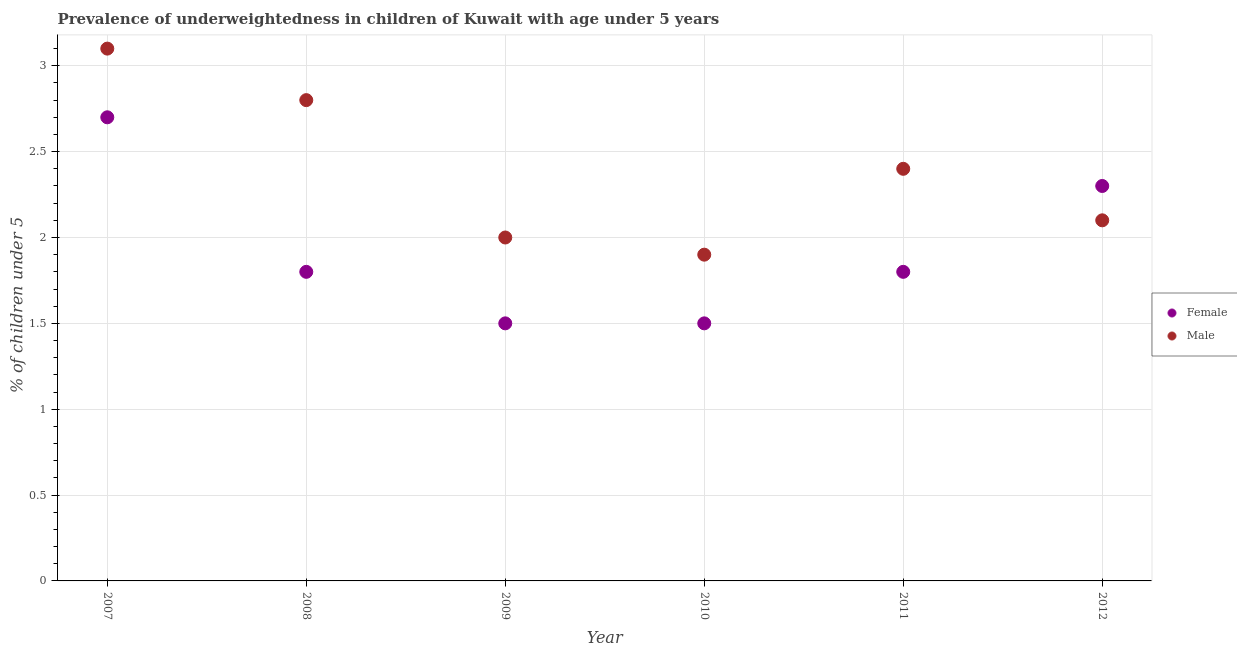How many different coloured dotlines are there?
Provide a short and direct response. 2. What is the percentage of underweighted female children in 2009?
Your answer should be very brief. 1.5. Across all years, what is the maximum percentage of underweighted male children?
Your answer should be compact. 3.1. Across all years, what is the minimum percentage of underweighted male children?
Your response must be concise. 1.9. In which year was the percentage of underweighted female children maximum?
Keep it short and to the point. 2007. In which year was the percentage of underweighted male children minimum?
Offer a terse response. 2010. What is the total percentage of underweighted male children in the graph?
Your response must be concise. 14.3. What is the difference between the percentage of underweighted female children in 2009 and that in 2011?
Provide a short and direct response. -0.3. What is the difference between the percentage of underweighted male children in 2010 and the percentage of underweighted female children in 2008?
Provide a succinct answer. 0.1. What is the average percentage of underweighted female children per year?
Make the answer very short. 1.93. In the year 2009, what is the difference between the percentage of underweighted male children and percentage of underweighted female children?
Ensure brevity in your answer.  0.5. What is the ratio of the percentage of underweighted female children in 2007 to that in 2011?
Give a very brief answer. 1.5. What is the difference between the highest and the second highest percentage of underweighted female children?
Offer a very short reply. 0.4. What is the difference between the highest and the lowest percentage of underweighted male children?
Your answer should be compact. 1.2. In how many years, is the percentage of underweighted female children greater than the average percentage of underweighted female children taken over all years?
Provide a short and direct response. 2. Does the percentage of underweighted female children monotonically increase over the years?
Provide a short and direct response. No. How many dotlines are there?
Offer a very short reply. 2. Are the values on the major ticks of Y-axis written in scientific E-notation?
Offer a very short reply. No. Does the graph contain any zero values?
Provide a succinct answer. No. Does the graph contain grids?
Offer a terse response. Yes. How are the legend labels stacked?
Provide a succinct answer. Vertical. What is the title of the graph?
Offer a very short reply. Prevalence of underweightedness in children of Kuwait with age under 5 years. Does "Nitrous oxide emissions" appear as one of the legend labels in the graph?
Offer a terse response. No. What is the label or title of the X-axis?
Keep it short and to the point. Year. What is the label or title of the Y-axis?
Ensure brevity in your answer.   % of children under 5. What is the  % of children under 5 in Female in 2007?
Provide a succinct answer. 2.7. What is the  % of children under 5 in Male in 2007?
Provide a succinct answer. 3.1. What is the  % of children under 5 in Female in 2008?
Offer a terse response. 1.8. What is the  % of children under 5 of Male in 2008?
Make the answer very short. 2.8. What is the  % of children under 5 of Female in 2009?
Offer a very short reply. 1.5. What is the  % of children under 5 in Male in 2010?
Keep it short and to the point. 1.9. What is the  % of children under 5 in Female in 2011?
Give a very brief answer. 1.8. What is the  % of children under 5 of Male in 2011?
Your answer should be compact. 2.4. What is the  % of children under 5 in Female in 2012?
Give a very brief answer. 2.3. What is the  % of children under 5 in Male in 2012?
Your answer should be very brief. 2.1. Across all years, what is the maximum  % of children under 5 of Female?
Your answer should be compact. 2.7. Across all years, what is the maximum  % of children under 5 of Male?
Your response must be concise. 3.1. Across all years, what is the minimum  % of children under 5 of Female?
Your answer should be compact. 1.5. Across all years, what is the minimum  % of children under 5 of Male?
Keep it short and to the point. 1.9. What is the total  % of children under 5 of Male in the graph?
Give a very brief answer. 14.3. What is the difference between the  % of children under 5 in Female in 2007 and that in 2008?
Your answer should be compact. 0.9. What is the difference between the  % of children under 5 of Male in 2007 and that in 2008?
Make the answer very short. 0.3. What is the difference between the  % of children under 5 in Female in 2007 and that in 2009?
Provide a short and direct response. 1.2. What is the difference between the  % of children under 5 of Female in 2007 and that in 2012?
Make the answer very short. 0.4. What is the difference between the  % of children under 5 in Male in 2007 and that in 2012?
Your response must be concise. 1. What is the difference between the  % of children under 5 in Female in 2008 and that in 2009?
Make the answer very short. 0.3. What is the difference between the  % of children under 5 in Male in 2008 and that in 2009?
Offer a very short reply. 0.8. What is the difference between the  % of children under 5 in Female in 2008 and that in 2011?
Ensure brevity in your answer.  0. What is the difference between the  % of children under 5 in Female in 2008 and that in 2012?
Ensure brevity in your answer.  -0.5. What is the difference between the  % of children under 5 of Male in 2008 and that in 2012?
Make the answer very short. 0.7. What is the difference between the  % of children under 5 of Female in 2009 and that in 2010?
Ensure brevity in your answer.  0. What is the difference between the  % of children under 5 of Male in 2009 and that in 2010?
Your response must be concise. 0.1. What is the difference between the  % of children under 5 of Female in 2009 and that in 2011?
Offer a very short reply. -0.3. What is the difference between the  % of children under 5 in Male in 2009 and that in 2011?
Your response must be concise. -0.4. What is the difference between the  % of children under 5 in Female in 2009 and that in 2012?
Offer a very short reply. -0.8. What is the difference between the  % of children under 5 in Male in 2009 and that in 2012?
Your answer should be very brief. -0.1. What is the difference between the  % of children under 5 in Female in 2010 and that in 2011?
Your answer should be compact. -0.3. What is the difference between the  % of children under 5 in Female in 2011 and that in 2012?
Provide a succinct answer. -0.5. What is the difference between the  % of children under 5 in Male in 2011 and that in 2012?
Ensure brevity in your answer.  0.3. What is the difference between the  % of children under 5 in Female in 2007 and the  % of children under 5 in Male in 2008?
Offer a terse response. -0.1. What is the difference between the  % of children under 5 of Female in 2007 and the  % of children under 5 of Male in 2011?
Your response must be concise. 0.3. What is the difference between the  % of children under 5 of Female in 2008 and the  % of children under 5 of Male in 2009?
Your response must be concise. -0.2. What is the difference between the  % of children under 5 of Female in 2008 and the  % of children under 5 of Male in 2011?
Provide a succinct answer. -0.6. What is the difference between the  % of children under 5 of Female in 2009 and the  % of children under 5 of Male in 2010?
Provide a short and direct response. -0.4. What is the difference between the  % of children under 5 of Female in 2009 and the  % of children under 5 of Male in 2011?
Your answer should be very brief. -0.9. What is the difference between the  % of children under 5 in Female in 2009 and the  % of children under 5 in Male in 2012?
Provide a short and direct response. -0.6. What is the difference between the  % of children under 5 in Female in 2010 and the  % of children under 5 in Male in 2012?
Give a very brief answer. -0.6. What is the difference between the  % of children under 5 in Female in 2011 and the  % of children under 5 in Male in 2012?
Keep it short and to the point. -0.3. What is the average  % of children under 5 in Female per year?
Offer a terse response. 1.93. What is the average  % of children under 5 of Male per year?
Your answer should be compact. 2.38. In the year 2007, what is the difference between the  % of children under 5 of Female and  % of children under 5 of Male?
Ensure brevity in your answer.  -0.4. In the year 2009, what is the difference between the  % of children under 5 of Female and  % of children under 5 of Male?
Ensure brevity in your answer.  -0.5. In the year 2012, what is the difference between the  % of children under 5 in Female and  % of children under 5 in Male?
Offer a terse response. 0.2. What is the ratio of the  % of children under 5 in Male in 2007 to that in 2008?
Your response must be concise. 1.11. What is the ratio of the  % of children under 5 in Male in 2007 to that in 2009?
Your answer should be very brief. 1.55. What is the ratio of the  % of children under 5 of Female in 2007 to that in 2010?
Offer a very short reply. 1.8. What is the ratio of the  % of children under 5 of Male in 2007 to that in 2010?
Provide a succinct answer. 1.63. What is the ratio of the  % of children under 5 in Female in 2007 to that in 2011?
Your response must be concise. 1.5. What is the ratio of the  % of children under 5 of Male in 2007 to that in 2011?
Provide a succinct answer. 1.29. What is the ratio of the  % of children under 5 of Female in 2007 to that in 2012?
Give a very brief answer. 1.17. What is the ratio of the  % of children under 5 of Male in 2007 to that in 2012?
Your answer should be very brief. 1.48. What is the ratio of the  % of children under 5 of Female in 2008 to that in 2009?
Offer a terse response. 1.2. What is the ratio of the  % of children under 5 of Male in 2008 to that in 2009?
Offer a very short reply. 1.4. What is the ratio of the  % of children under 5 of Male in 2008 to that in 2010?
Provide a succinct answer. 1.47. What is the ratio of the  % of children under 5 in Female in 2008 to that in 2012?
Your answer should be very brief. 0.78. What is the ratio of the  % of children under 5 of Female in 2009 to that in 2010?
Offer a very short reply. 1. What is the ratio of the  % of children under 5 in Male in 2009 to that in 2010?
Give a very brief answer. 1.05. What is the ratio of the  % of children under 5 of Female in 2009 to that in 2011?
Your answer should be very brief. 0.83. What is the ratio of the  % of children under 5 of Female in 2009 to that in 2012?
Give a very brief answer. 0.65. What is the ratio of the  % of children under 5 of Male in 2009 to that in 2012?
Make the answer very short. 0.95. What is the ratio of the  % of children under 5 of Male in 2010 to that in 2011?
Give a very brief answer. 0.79. What is the ratio of the  % of children under 5 of Female in 2010 to that in 2012?
Offer a very short reply. 0.65. What is the ratio of the  % of children under 5 in Male in 2010 to that in 2012?
Your response must be concise. 0.9. What is the ratio of the  % of children under 5 in Female in 2011 to that in 2012?
Your answer should be compact. 0.78. What is the ratio of the  % of children under 5 of Male in 2011 to that in 2012?
Give a very brief answer. 1.14. What is the difference between the highest and the second highest  % of children under 5 in Male?
Give a very brief answer. 0.3. What is the difference between the highest and the lowest  % of children under 5 of Male?
Offer a very short reply. 1.2. 